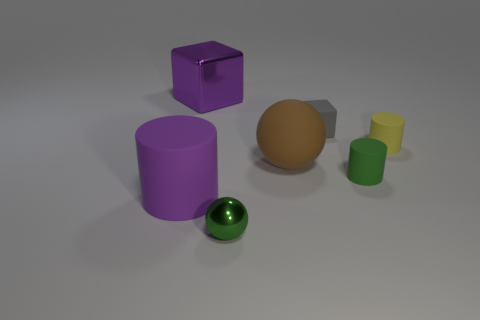There is another object that is the same color as the big metal thing; what is its shape?
Provide a succinct answer. Cylinder. What number of other objects are there of the same shape as the tiny yellow rubber thing?
Your response must be concise. 2. What shape is the brown thing that is made of the same material as the gray object?
Give a very brief answer. Sphere. There is a cube that is the same size as the purple rubber object; what color is it?
Give a very brief answer. Purple. Do the sphere that is in front of the brown matte object and the small gray block have the same size?
Keep it short and to the point. Yes. Do the big metallic object and the small cube have the same color?
Offer a terse response. No. What number of big purple objects are there?
Provide a succinct answer. 2. How many cylinders are brown rubber objects or purple metal things?
Give a very brief answer. 0. How many green rubber cylinders are behind the cube that is to the right of the metal cube?
Your answer should be very brief. 0. Is the large sphere made of the same material as the purple cylinder?
Your answer should be compact. Yes. 